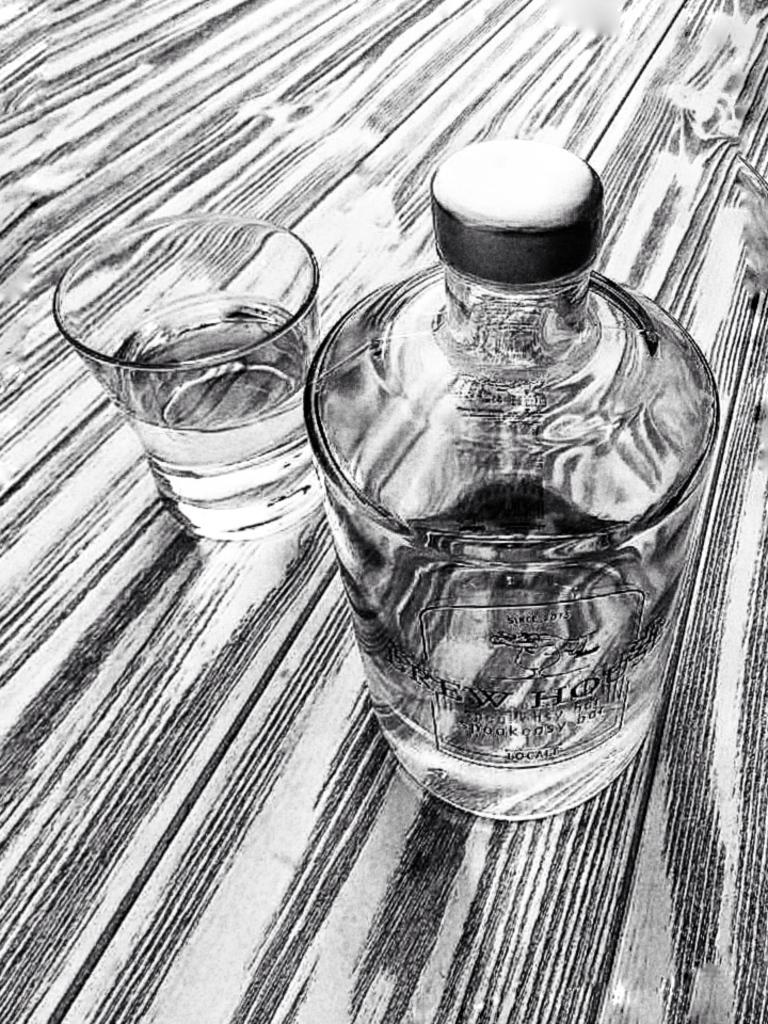What type of container is visible in the image? There is a glass bottle and a glass of water in the image. Where are the glass bottle and the glass of water located? Both the glass bottle and the glass of water are placed on a table. What is the primary difference between the two containers in the image? The glass bottle is likely filled with a different liquid than the glass of water. What letter is written on the cap of the glass bottle in the image? There is no cap visible on the glass bottle in the image. 